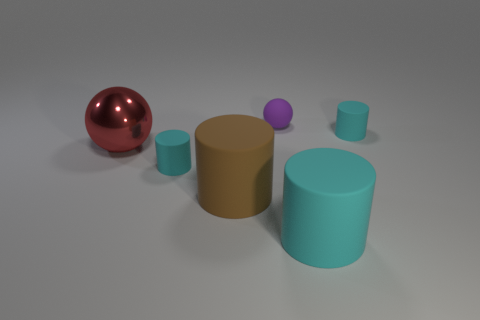What is the shape of the cyan rubber thing behind the tiny rubber object in front of the big shiny object?
Keep it short and to the point. Cylinder. What number of tiny cyan objects are both right of the large cyan object and on the left side of the big brown cylinder?
Ensure brevity in your answer.  0. There is a cyan matte object that is left of the brown cylinder; how many rubber objects are in front of it?
Offer a terse response. 2. What number of things are either small things behind the big cyan rubber thing or cyan objects that are behind the red ball?
Keep it short and to the point. 3. What is the material of the other thing that is the same shape as the large red object?
Provide a succinct answer. Rubber. How many objects are matte things that are left of the small rubber ball or brown objects?
Offer a very short reply. 2. The purple thing that is made of the same material as the big cyan cylinder is what shape?
Keep it short and to the point. Sphere. What number of small cyan matte objects are the same shape as the big brown object?
Provide a succinct answer. 2. What material is the small purple sphere?
Keep it short and to the point. Rubber. What number of balls are small yellow shiny things or large cyan objects?
Provide a short and direct response. 0. 